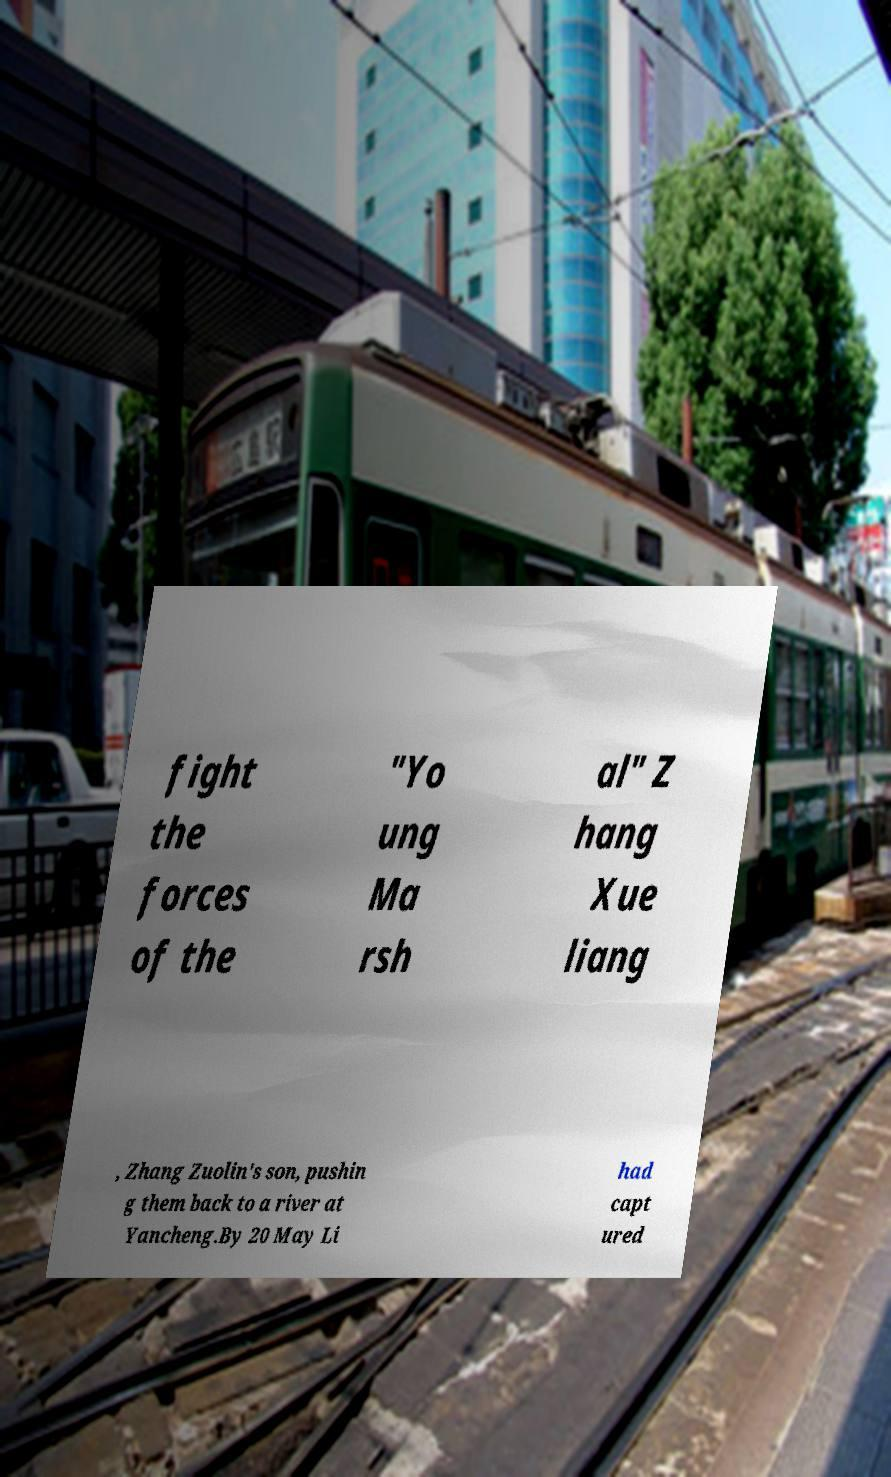What messages or text are displayed in this image? I need them in a readable, typed format. fight the forces of the "Yo ung Ma rsh al" Z hang Xue liang , Zhang Zuolin's son, pushin g them back to a river at Yancheng.By 20 May Li had capt ured 